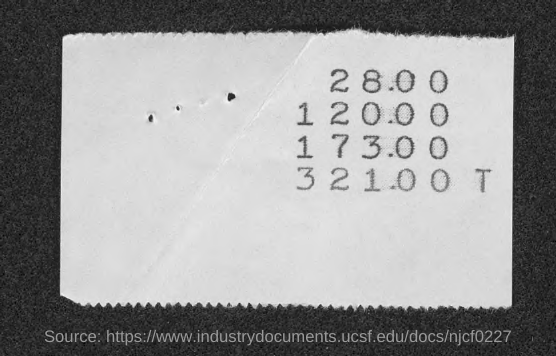Identify some key points in this picture. The first amount given in the slip is 28.00. The second amount mentioned on the slip is 120.00. 